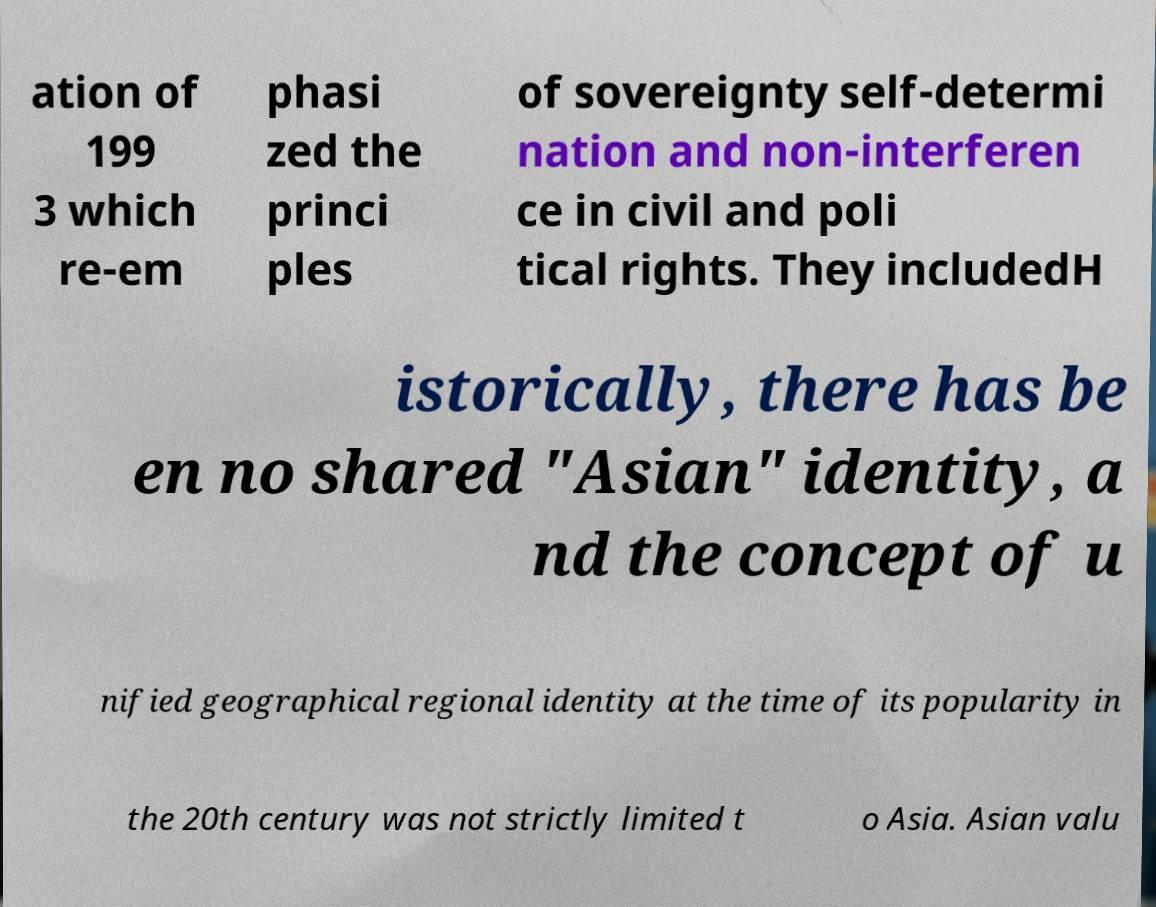What messages or text are displayed in this image? I need them in a readable, typed format. ation of 199 3 which re-em phasi zed the princi ples of sovereignty self-determi nation and non-interferen ce in civil and poli tical rights. They includedH istorically, there has be en no shared "Asian" identity, a nd the concept of u nified geographical regional identity at the time of its popularity in the 20th century was not strictly limited t o Asia. Asian valu 